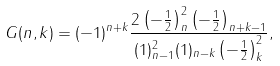Convert formula to latex. <formula><loc_0><loc_0><loc_500><loc_500>G ( n , k ) = ( - 1 ) ^ { n + k } \frac { 2 \left ( - \frac { 1 } { 2 } \right ) _ { n } ^ { 2 } \left ( - \frac { 1 } { 2 } \right ) _ { n + k - 1 } } { ( 1 ) _ { n - 1 } ^ { 2 } ( 1 ) _ { n - k } \left ( - \frac { 1 } { 2 } \right ) _ { k } ^ { 2 } } ,</formula> 